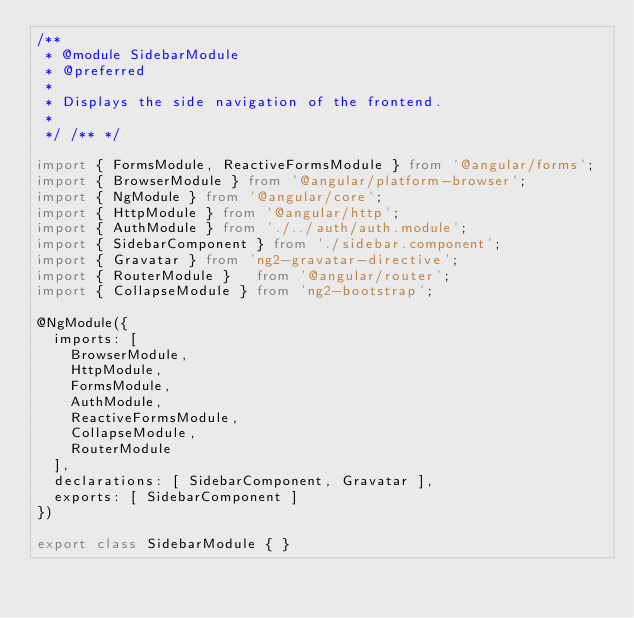Convert code to text. <code><loc_0><loc_0><loc_500><loc_500><_TypeScript_>/**
 * @module SidebarModule
 * @preferred
 * 
 * Displays the side navigation of the frontend.
 * 
 */ /** */

import { FormsModule, ReactiveFormsModule } from '@angular/forms';
import { BrowserModule } from '@angular/platform-browser';
import { NgModule } from '@angular/core';
import { HttpModule } from '@angular/http';
import { AuthModule } from './../auth/auth.module';
import { SidebarComponent } from './sidebar.component';
import { Gravatar } from 'ng2-gravatar-directive';
import { RouterModule }   from '@angular/router';
import { CollapseModule } from 'ng2-bootstrap';

@NgModule({
  imports: [
    BrowserModule,
    HttpModule,
    FormsModule,
    AuthModule,
    ReactiveFormsModule,
    CollapseModule,
    RouterModule
  ],
  declarations: [ SidebarComponent, Gravatar ],
  exports: [ SidebarComponent ]
})

export class SidebarModule { }
</code> 